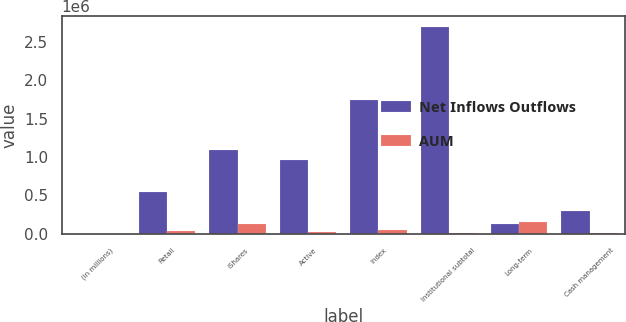Convert chart to OTSL. <chart><loc_0><loc_0><loc_500><loc_500><stacked_bar_chart><ecel><fcel>(in millions)<fcel>Retail<fcel>iShares<fcel>Active<fcel>Index<fcel>Institutional subtotal<fcel>Long-term<fcel>Cash management<nl><fcel>Net Inflows Outflows<fcel>2015<fcel>541125<fcel>1.09256e+06<fcel>962852<fcel>1.73878e+06<fcel>2.70163e+06<fcel>129852<fcel>299884<nl><fcel>AUM<fcel>2015<fcel>38512<fcel>129852<fcel>26746<fcel>43096<fcel>16350<fcel>152014<fcel>7510<nl></chart> 